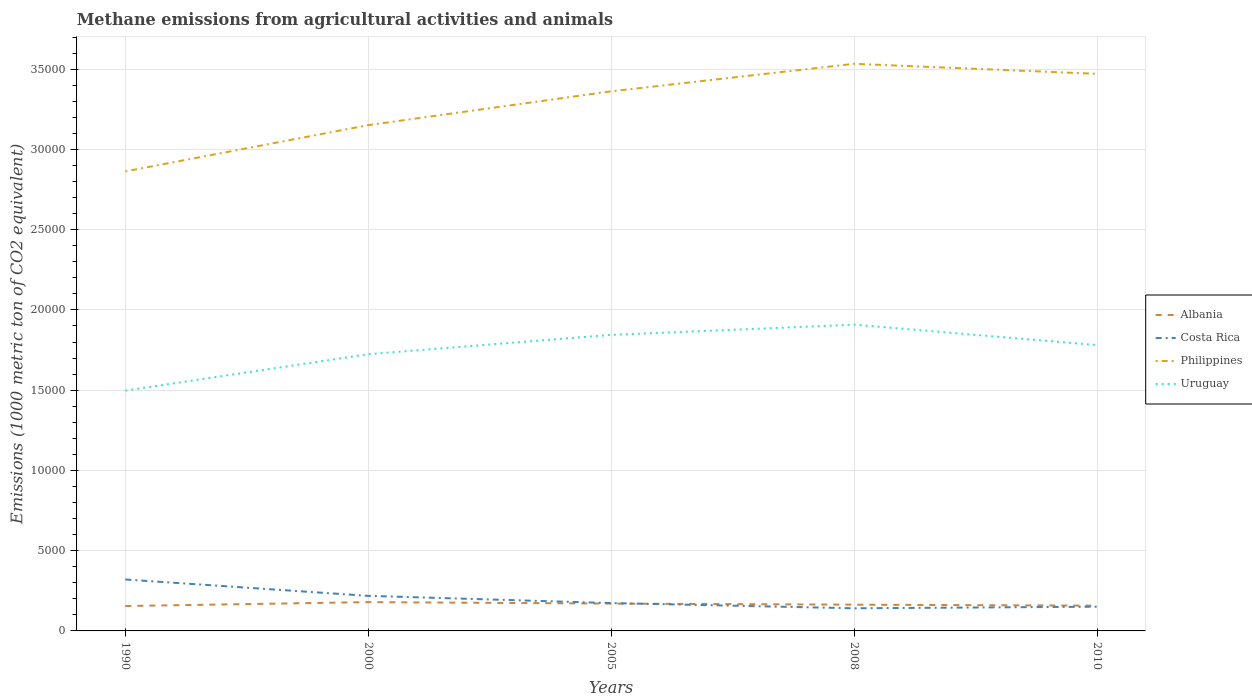How many different coloured lines are there?
Make the answer very short. 4. Is the number of lines equal to the number of legend labels?
Make the answer very short. Yes. Across all years, what is the maximum amount of methane emitted in Philippines?
Offer a very short reply. 2.86e+04. In which year was the amount of methane emitted in Costa Rica maximum?
Keep it short and to the point. 2008. What is the total amount of methane emitted in Costa Rica in the graph?
Your response must be concise. 1020. What is the difference between the highest and the second highest amount of methane emitted in Philippines?
Provide a short and direct response. 6703.2. How many lines are there?
Make the answer very short. 4. How many years are there in the graph?
Make the answer very short. 5. Are the values on the major ticks of Y-axis written in scientific E-notation?
Offer a terse response. No. Does the graph contain any zero values?
Offer a terse response. No. Does the graph contain grids?
Make the answer very short. Yes. How are the legend labels stacked?
Ensure brevity in your answer.  Vertical. What is the title of the graph?
Your answer should be very brief. Methane emissions from agricultural activities and animals. Does "Angola" appear as one of the legend labels in the graph?
Keep it short and to the point. No. What is the label or title of the X-axis?
Keep it short and to the point. Years. What is the label or title of the Y-axis?
Your response must be concise. Emissions (1000 metric ton of CO2 equivalent). What is the Emissions (1000 metric ton of CO2 equivalent) of Albania in 1990?
Offer a very short reply. 1550.9. What is the Emissions (1000 metric ton of CO2 equivalent) in Costa Rica in 1990?
Your answer should be very brief. 3204.6. What is the Emissions (1000 metric ton of CO2 equivalent) in Philippines in 1990?
Provide a succinct answer. 2.86e+04. What is the Emissions (1000 metric ton of CO2 equivalent) in Uruguay in 1990?
Ensure brevity in your answer.  1.50e+04. What is the Emissions (1000 metric ton of CO2 equivalent) of Albania in 2000?
Give a very brief answer. 1794.6. What is the Emissions (1000 metric ton of CO2 equivalent) of Costa Rica in 2000?
Keep it short and to the point. 2184.6. What is the Emissions (1000 metric ton of CO2 equivalent) in Philippines in 2000?
Offer a terse response. 3.15e+04. What is the Emissions (1000 metric ton of CO2 equivalent) in Uruguay in 2000?
Your answer should be very brief. 1.72e+04. What is the Emissions (1000 metric ton of CO2 equivalent) of Albania in 2005?
Offer a very short reply. 1702.9. What is the Emissions (1000 metric ton of CO2 equivalent) of Costa Rica in 2005?
Offer a very short reply. 1735. What is the Emissions (1000 metric ton of CO2 equivalent) in Philippines in 2005?
Offer a very short reply. 3.36e+04. What is the Emissions (1000 metric ton of CO2 equivalent) of Uruguay in 2005?
Offer a terse response. 1.84e+04. What is the Emissions (1000 metric ton of CO2 equivalent) of Albania in 2008?
Ensure brevity in your answer.  1635.8. What is the Emissions (1000 metric ton of CO2 equivalent) in Costa Rica in 2008?
Your response must be concise. 1409.6. What is the Emissions (1000 metric ton of CO2 equivalent) of Philippines in 2008?
Offer a terse response. 3.53e+04. What is the Emissions (1000 metric ton of CO2 equivalent) in Uruguay in 2008?
Offer a terse response. 1.91e+04. What is the Emissions (1000 metric ton of CO2 equivalent) in Albania in 2010?
Provide a short and direct response. 1574.1. What is the Emissions (1000 metric ton of CO2 equivalent) in Costa Rica in 2010?
Give a very brief answer. 1509.2. What is the Emissions (1000 metric ton of CO2 equivalent) of Philippines in 2010?
Your answer should be very brief. 3.47e+04. What is the Emissions (1000 metric ton of CO2 equivalent) in Uruguay in 2010?
Give a very brief answer. 1.78e+04. Across all years, what is the maximum Emissions (1000 metric ton of CO2 equivalent) of Albania?
Your answer should be very brief. 1794.6. Across all years, what is the maximum Emissions (1000 metric ton of CO2 equivalent) of Costa Rica?
Ensure brevity in your answer.  3204.6. Across all years, what is the maximum Emissions (1000 metric ton of CO2 equivalent) in Philippines?
Your answer should be very brief. 3.53e+04. Across all years, what is the maximum Emissions (1000 metric ton of CO2 equivalent) in Uruguay?
Your response must be concise. 1.91e+04. Across all years, what is the minimum Emissions (1000 metric ton of CO2 equivalent) of Albania?
Provide a short and direct response. 1550.9. Across all years, what is the minimum Emissions (1000 metric ton of CO2 equivalent) of Costa Rica?
Provide a short and direct response. 1409.6. Across all years, what is the minimum Emissions (1000 metric ton of CO2 equivalent) in Philippines?
Offer a very short reply. 2.86e+04. Across all years, what is the minimum Emissions (1000 metric ton of CO2 equivalent) in Uruguay?
Offer a very short reply. 1.50e+04. What is the total Emissions (1000 metric ton of CO2 equivalent) of Albania in the graph?
Ensure brevity in your answer.  8258.3. What is the total Emissions (1000 metric ton of CO2 equivalent) in Costa Rica in the graph?
Ensure brevity in your answer.  1.00e+04. What is the total Emissions (1000 metric ton of CO2 equivalent) in Philippines in the graph?
Give a very brief answer. 1.64e+05. What is the total Emissions (1000 metric ton of CO2 equivalent) of Uruguay in the graph?
Provide a succinct answer. 8.75e+04. What is the difference between the Emissions (1000 metric ton of CO2 equivalent) of Albania in 1990 and that in 2000?
Give a very brief answer. -243.7. What is the difference between the Emissions (1000 metric ton of CO2 equivalent) in Costa Rica in 1990 and that in 2000?
Keep it short and to the point. 1020. What is the difference between the Emissions (1000 metric ton of CO2 equivalent) in Philippines in 1990 and that in 2000?
Offer a terse response. -2881.3. What is the difference between the Emissions (1000 metric ton of CO2 equivalent) of Uruguay in 1990 and that in 2000?
Provide a succinct answer. -2267.7. What is the difference between the Emissions (1000 metric ton of CO2 equivalent) in Albania in 1990 and that in 2005?
Make the answer very short. -152. What is the difference between the Emissions (1000 metric ton of CO2 equivalent) in Costa Rica in 1990 and that in 2005?
Your answer should be very brief. 1469.6. What is the difference between the Emissions (1000 metric ton of CO2 equivalent) in Philippines in 1990 and that in 2005?
Keep it short and to the point. -4989.5. What is the difference between the Emissions (1000 metric ton of CO2 equivalent) in Uruguay in 1990 and that in 2005?
Your response must be concise. -3472.5. What is the difference between the Emissions (1000 metric ton of CO2 equivalent) of Albania in 1990 and that in 2008?
Keep it short and to the point. -84.9. What is the difference between the Emissions (1000 metric ton of CO2 equivalent) of Costa Rica in 1990 and that in 2008?
Ensure brevity in your answer.  1795. What is the difference between the Emissions (1000 metric ton of CO2 equivalent) in Philippines in 1990 and that in 2008?
Ensure brevity in your answer.  -6703.2. What is the difference between the Emissions (1000 metric ton of CO2 equivalent) in Uruguay in 1990 and that in 2008?
Your answer should be compact. -4108.2. What is the difference between the Emissions (1000 metric ton of CO2 equivalent) in Albania in 1990 and that in 2010?
Provide a succinct answer. -23.2. What is the difference between the Emissions (1000 metric ton of CO2 equivalent) in Costa Rica in 1990 and that in 2010?
Make the answer very short. 1695.4. What is the difference between the Emissions (1000 metric ton of CO2 equivalent) in Philippines in 1990 and that in 2010?
Your response must be concise. -6077.5. What is the difference between the Emissions (1000 metric ton of CO2 equivalent) of Uruguay in 1990 and that in 2010?
Your answer should be very brief. -2833.1. What is the difference between the Emissions (1000 metric ton of CO2 equivalent) of Albania in 2000 and that in 2005?
Provide a short and direct response. 91.7. What is the difference between the Emissions (1000 metric ton of CO2 equivalent) in Costa Rica in 2000 and that in 2005?
Your answer should be very brief. 449.6. What is the difference between the Emissions (1000 metric ton of CO2 equivalent) of Philippines in 2000 and that in 2005?
Offer a terse response. -2108.2. What is the difference between the Emissions (1000 metric ton of CO2 equivalent) in Uruguay in 2000 and that in 2005?
Make the answer very short. -1204.8. What is the difference between the Emissions (1000 metric ton of CO2 equivalent) of Albania in 2000 and that in 2008?
Make the answer very short. 158.8. What is the difference between the Emissions (1000 metric ton of CO2 equivalent) of Costa Rica in 2000 and that in 2008?
Give a very brief answer. 775. What is the difference between the Emissions (1000 metric ton of CO2 equivalent) in Philippines in 2000 and that in 2008?
Offer a terse response. -3821.9. What is the difference between the Emissions (1000 metric ton of CO2 equivalent) of Uruguay in 2000 and that in 2008?
Your answer should be compact. -1840.5. What is the difference between the Emissions (1000 metric ton of CO2 equivalent) in Albania in 2000 and that in 2010?
Make the answer very short. 220.5. What is the difference between the Emissions (1000 metric ton of CO2 equivalent) of Costa Rica in 2000 and that in 2010?
Ensure brevity in your answer.  675.4. What is the difference between the Emissions (1000 metric ton of CO2 equivalent) of Philippines in 2000 and that in 2010?
Make the answer very short. -3196.2. What is the difference between the Emissions (1000 metric ton of CO2 equivalent) in Uruguay in 2000 and that in 2010?
Provide a short and direct response. -565.4. What is the difference between the Emissions (1000 metric ton of CO2 equivalent) in Albania in 2005 and that in 2008?
Your answer should be very brief. 67.1. What is the difference between the Emissions (1000 metric ton of CO2 equivalent) of Costa Rica in 2005 and that in 2008?
Make the answer very short. 325.4. What is the difference between the Emissions (1000 metric ton of CO2 equivalent) of Philippines in 2005 and that in 2008?
Give a very brief answer. -1713.7. What is the difference between the Emissions (1000 metric ton of CO2 equivalent) of Uruguay in 2005 and that in 2008?
Your answer should be compact. -635.7. What is the difference between the Emissions (1000 metric ton of CO2 equivalent) in Albania in 2005 and that in 2010?
Your answer should be compact. 128.8. What is the difference between the Emissions (1000 metric ton of CO2 equivalent) in Costa Rica in 2005 and that in 2010?
Offer a terse response. 225.8. What is the difference between the Emissions (1000 metric ton of CO2 equivalent) in Philippines in 2005 and that in 2010?
Your answer should be compact. -1088. What is the difference between the Emissions (1000 metric ton of CO2 equivalent) of Uruguay in 2005 and that in 2010?
Your answer should be very brief. 639.4. What is the difference between the Emissions (1000 metric ton of CO2 equivalent) of Albania in 2008 and that in 2010?
Your answer should be compact. 61.7. What is the difference between the Emissions (1000 metric ton of CO2 equivalent) in Costa Rica in 2008 and that in 2010?
Offer a terse response. -99.6. What is the difference between the Emissions (1000 metric ton of CO2 equivalent) of Philippines in 2008 and that in 2010?
Provide a short and direct response. 625.7. What is the difference between the Emissions (1000 metric ton of CO2 equivalent) in Uruguay in 2008 and that in 2010?
Your answer should be compact. 1275.1. What is the difference between the Emissions (1000 metric ton of CO2 equivalent) of Albania in 1990 and the Emissions (1000 metric ton of CO2 equivalent) of Costa Rica in 2000?
Your response must be concise. -633.7. What is the difference between the Emissions (1000 metric ton of CO2 equivalent) in Albania in 1990 and the Emissions (1000 metric ton of CO2 equivalent) in Philippines in 2000?
Your response must be concise. -3.00e+04. What is the difference between the Emissions (1000 metric ton of CO2 equivalent) of Albania in 1990 and the Emissions (1000 metric ton of CO2 equivalent) of Uruguay in 2000?
Make the answer very short. -1.57e+04. What is the difference between the Emissions (1000 metric ton of CO2 equivalent) of Costa Rica in 1990 and the Emissions (1000 metric ton of CO2 equivalent) of Philippines in 2000?
Make the answer very short. -2.83e+04. What is the difference between the Emissions (1000 metric ton of CO2 equivalent) in Costa Rica in 1990 and the Emissions (1000 metric ton of CO2 equivalent) in Uruguay in 2000?
Offer a very short reply. -1.40e+04. What is the difference between the Emissions (1000 metric ton of CO2 equivalent) of Philippines in 1990 and the Emissions (1000 metric ton of CO2 equivalent) of Uruguay in 2000?
Provide a short and direct response. 1.14e+04. What is the difference between the Emissions (1000 metric ton of CO2 equivalent) of Albania in 1990 and the Emissions (1000 metric ton of CO2 equivalent) of Costa Rica in 2005?
Your answer should be very brief. -184.1. What is the difference between the Emissions (1000 metric ton of CO2 equivalent) of Albania in 1990 and the Emissions (1000 metric ton of CO2 equivalent) of Philippines in 2005?
Make the answer very short. -3.21e+04. What is the difference between the Emissions (1000 metric ton of CO2 equivalent) in Albania in 1990 and the Emissions (1000 metric ton of CO2 equivalent) in Uruguay in 2005?
Give a very brief answer. -1.69e+04. What is the difference between the Emissions (1000 metric ton of CO2 equivalent) of Costa Rica in 1990 and the Emissions (1000 metric ton of CO2 equivalent) of Philippines in 2005?
Your answer should be compact. -3.04e+04. What is the difference between the Emissions (1000 metric ton of CO2 equivalent) of Costa Rica in 1990 and the Emissions (1000 metric ton of CO2 equivalent) of Uruguay in 2005?
Give a very brief answer. -1.52e+04. What is the difference between the Emissions (1000 metric ton of CO2 equivalent) in Philippines in 1990 and the Emissions (1000 metric ton of CO2 equivalent) in Uruguay in 2005?
Offer a very short reply. 1.02e+04. What is the difference between the Emissions (1000 metric ton of CO2 equivalent) of Albania in 1990 and the Emissions (1000 metric ton of CO2 equivalent) of Costa Rica in 2008?
Offer a very short reply. 141.3. What is the difference between the Emissions (1000 metric ton of CO2 equivalent) in Albania in 1990 and the Emissions (1000 metric ton of CO2 equivalent) in Philippines in 2008?
Provide a succinct answer. -3.38e+04. What is the difference between the Emissions (1000 metric ton of CO2 equivalent) in Albania in 1990 and the Emissions (1000 metric ton of CO2 equivalent) in Uruguay in 2008?
Provide a short and direct response. -1.75e+04. What is the difference between the Emissions (1000 metric ton of CO2 equivalent) of Costa Rica in 1990 and the Emissions (1000 metric ton of CO2 equivalent) of Philippines in 2008?
Keep it short and to the point. -3.21e+04. What is the difference between the Emissions (1000 metric ton of CO2 equivalent) of Costa Rica in 1990 and the Emissions (1000 metric ton of CO2 equivalent) of Uruguay in 2008?
Your answer should be very brief. -1.59e+04. What is the difference between the Emissions (1000 metric ton of CO2 equivalent) in Philippines in 1990 and the Emissions (1000 metric ton of CO2 equivalent) in Uruguay in 2008?
Give a very brief answer. 9549.1. What is the difference between the Emissions (1000 metric ton of CO2 equivalent) in Albania in 1990 and the Emissions (1000 metric ton of CO2 equivalent) in Costa Rica in 2010?
Offer a terse response. 41.7. What is the difference between the Emissions (1000 metric ton of CO2 equivalent) of Albania in 1990 and the Emissions (1000 metric ton of CO2 equivalent) of Philippines in 2010?
Your answer should be compact. -3.32e+04. What is the difference between the Emissions (1000 metric ton of CO2 equivalent) of Albania in 1990 and the Emissions (1000 metric ton of CO2 equivalent) of Uruguay in 2010?
Give a very brief answer. -1.63e+04. What is the difference between the Emissions (1000 metric ton of CO2 equivalent) in Costa Rica in 1990 and the Emissions (1000 metric ton of CO2 equivalent) in Philippines in 2010?
Make the answer very short. -3.15e+04. What is the difference between the Emissions (1000 metric ton of CO2 equivalent) in Costa Rica in 1990 and the Emissions (1000 metric ton of CO2 equivalent) in Uruguay in 2010?
Your answer should be very brief. -1.46e+04. What is the difference between the Emissions (1000 metric ton of CO2 equivalent) of Philippines in 1990 and the Emissions (1000 metric ton of CO2 equivalent) of Uruguay in 2010?
Make the answer very short. 1.08e+04. What is the difference between the Emissions (1000 metric ton of CO2 equivalent) in Albania in 2000 and the Emissions (1000 metric ton of CO2 equivalent) in Costa Rica in 2005?
Your answer should be compact. 59.6. What is the difference between the Emissions (1000 metric ton of CO2 equivalent) of Albania in 2000 and the Emissions (1000 metric ton of CO2 equivalent) of Philippines in 2005?
Offer a terse response. -3.18e+04. What is the difference between the Emissions (1000 metric ton of CO2 equivalent) of Albania in 2000 and the Emissions (1000 metric ton of CO2 equivalent) of Uruguay in 2005?
Ensure brevity in your answer.  -1.67e+04. What is the difference between the Emissions (1000 metric ton of CO2 equivalent) in Costa Rica in 2000 and the Emissions (1000 metric ton of CO2 equivalent) in Philippines in 2005?
Your response must be concise. -3.14e+04. What is the difference between the Emissions (1000 metric ton of CO2 equivalent) in Costa Rica in 2000 and the Emissions (1000 metric ton of CO2 equivalent) in Uruguay in 2005?
Your response must be concise. -1.63e+04. What is the difference between the Emissions (1000 metric ton of CO2 equivalent) in Philippines in 2000 and the Emissions (1000 metric ton of CO2 equivalent) in Uruguay in 2005?
Your response must be concise. 1.31e+04. What is the difference between the Emissions (1000 metric ton of CO2 equivalent) in Albania in 2000 and the Emissions (1000 metric ton of CO2 equivalent) in Costa Rica in 2008?
Provide a short and direct response. 385. What is the difference between the Emissions (1000 metric ton of CO2 equivalent) in Albania in 2000 and the Emissions (1000 metric ton of CO2 equivalent) in Philippines in 2008?
Offer a very short reply. -3.35e+04. What is the difference between the Emissions (1000 metric ton of CO2 equivalent) of Albania in 2000 and the Emissions (1000 metric ton of CO2 equivalent) of Uruguay in 2008?
Keep it short and to the point. -1.73e+04. What is the difference between the Emissions (1000 metric ton of CO2 equivalent) of Costa Rica in 2000 and the Emissions (1000 metric ton of CO2 equivalent) of Philippines in 2008?
Keep it short and to the point. -3.31e+04. What is the difference between the Emissions (1000 metric ton of CO2 equivalent) of Costa Rica in 2000 and the Emissions (1000 metric ton of CO2 equivalent) of Uruguay in 2008?
Make the answer very short. -1.69e+04. What is the difference between the Emissions (1000 metric ton of CO2 equivalent) of Philippines in 2000 and the Emissions (1000 metric ton of CO2 equivalent) of Uruguay in 2008?
Offer a terse response. 1.24e+04. What is the difference between the Emissions (1000 metric ton of CO2 equivalent) in Albania in 2000 and the Emissions (1000 metric ton of CO2 equivalent) in Costa Rica in 2010?
Ensure brevity in your answer.  285.4. What is the difference between the Emissions (1000 metric ton of CO2 equivalent) in Albania in 2000 and the Emissions (1000 metric ton of CO2 equivalent) in Philippines in 2010?
Make the answer very short. -3.29e+04. What is the difference between the Emissions (1000 metric ton of CO2 equivalent) in Albania in 2000 and the Emissions (1000 metric ton of CO2 equivalent) in Uruguay in 2010?
Offer a very short reply. -1.60e+04. What is the difference between the Emissions (1000 metric ton of CO2 equivalent) in Costa Rica in 2000 and the Emissions (1000 metric ton of CO2 equivalent) in Philippines in 2010?
Make the answer very short. -3.25e+04. What is the difference between the Emissions (1000 metric ton of CO2 equivalent) in Costa Rica in 2000 and the Emissions (1000 metric ton of CO2 equivalent) in Uruguay in 2010?
Give a very brief answer. -1.56e+04. What is the difference between the Emissions (1000 metric ton of CO2 equivalent) in Philippines in 2000 and the Emissions (1000 metric ton of CO2 equivalent) in Uruguay in 2010?
Offer a very short reply. 1.37e+04. What is the difference between the Emissions (1000 metric ton of CO2 equivalent) in Albania in 2005 and the Emissions (1000 metric ton of CO2 equivalent) in Costa Rica in 2008?
Offer a terse response. 293.3. What is the difference between the Emissions (1000 metric ton of CO2 equivalent) in Albania in 2005 and the Emissions (1000 metric ton of CO2 equivalent) in Philippines in 2008?
Make the answer very short. -3.36e+04. What is the difference between the Emissions (1000 metric ton of CO2 equivalent) of Albania in 2005 and the Emissions (1000 metric ton of CO2 equivalent) of Uruguay in 2008?
Give a very brief answer. -1.74e+04. What is the difference between the Emissions (1000 metric ton of CO2 equivalent) of Costa Rica in 2005 and the Emissions (1000 metric ton of CO2 equivalent) of Philippines in 2008?
Your answer should be very brief. -3.36e+04. What is the difference between the Emissions (1000 metric ton of CO2 equivalent) of Costa Rica in 2005 and the Emissions (1000 metric ton of CO2 equivalent) of Uruguay in 2008?
Keep it short and to the point. -1.73e+04. What is the difference between the Emissions (1000 metric ton of CO2 equivalent) of Philippines in 2005 and the Emissions (1000 metric ton of CO2 equivalent) of Uruguay in 2008?
Give a very brief answer. 1.45e+04. What is the difference between the Emissions (1000 metric ton of CO2 equivalent) in Albania in 2005 and the Emissions (1000 metric ton of CO2 equivalent) in Costa Rica in 2010?
Your response must be concise. 193.7. What is the difference between the Emissions (1000 metric ton of CO2 equivalent) of Albania in 2005 and the Emissions (1000 metric ton of CO2 equivalent) of Philippines in 2010?
Offer a terse response. -3.30e+04. What is the difference between the Emissions (1000 metric ton of CO2 equivalent) in Albania in 2005 and the Emissions (1000 metric ton of CO2 equivalent) in Uruguay in 2010?
Keep it short and to the point. -1.61e+04. What is the difference between the Emissions (1000 metric ton of CO2 equivalent) of Costa Rica in 2005 and the Emissions (1000 metric ton of CO2 equivalent) of Philippines in 2010?
Provide a succinct answer. -3.30e+04. What is the difference between the Emissions (1000 metric ton of CO2 equivalent) of Costa Rica in 2005 and the Emissions (1000 metric ton of CO2 equivalent) of Uruguay in 2010?
Keep it short and to the point. -1.61e+04. What is the difference between the Emissions (1000 metric ton of CO2 equivalent) in Philippines in 2005 and the Emissions (1000 metric ton of CO2 equivalent) in Uruguay in 2010?
Your response must be concise. 1.58e+04. What is the difference between the Emissions (1000 metric ton of CO2 equivalent) of Albania in 2008 and the Emissions (1000 metric ton of CO2 equivalent) of Costa Rica in 2010?
Offer a terse response. 126.6. What is the difference between the Emissions (1000 metric ton of CO2 equivalent) in Albania in 2008 and the Emissions (1000 metric ton of CO2 equivalent) in Philippines in 2010?
Ensure brevity in your answer.  -3.31e+04. What is the difference between the Emissions (1000 metric ton of CO2 equivalent) of Albania in 2008 and the Emissions (1000 metric ton of CO2 equivalent) of Uruguay in 2010?
Your answer should be compact. -1.62e+04. What is the difference between the Emissions (1000 metric ton of CO2 equivalent) in Costa Rica in 2008 and the Emissions (1000 metric ton of CO2 equivalent) in Philippines in 2010?
Ensure brevity in your answer.  -3.33e+04. What is the difference between the Emissions (1000 metric ton of CO2 equivalent) of Costa Rica in 2008 and the Emissions (1000 metric ton of CO2 equivalent) of Uruguay in 2010?
Provide a short and direct response. -1.64e+04. What is the difference between the Emissions (1000 metric ton of CO2 equivalent) of Philippines in 2008 and the Emissions (1000 metric ton of CO2 equivalent) of Uruguay in 2010?
Your response must be concise. 1.75e+04. What is the average Emissions (1000 metric ton of CO2 equivalent) of Albania per year?
Ensure brevity in your answer.  1651.66. What is the average Emissions (1000 metric ton of CO2 equivalent) of Costa Rica per year?
Provide a succinct answer. 2008.6. What is the average Emissions (1000 metric ton of CO2 equivalent) of Philippines per year?
Offer a very short reply. 3.28e+04. What is the average Emissions (1000 metric ton of CO2 equivalent) in Uruguay per year?
Your answer should be very brief. 1.75e+04. In the year 1990, what is the difference between the Emissions (1000 metric ton of CO2 equivalent) in Albania and Emissions (1000 metric ton of CO2 equivalent) in Costa Rica?
Give a very brief answer. -1653.7. In the year 1990, what is the difference between the Emissions (1000 metric ton of CO2 equivalent) in Albania and Emissions (1000 metric ton of CO2 equivalent) in Philippines?
Ensure brevity in your answer.  -2.71e+04. In the year 1990, what is the difference between the Emissions (1000 metric ton of CO2 equivalent) of Albania and Emissions (1000 metric ton of CO2 equivalent) of Uruguay?
Offer a very short reply. -1.34e+04. In the year 1990, what is the difference between the Emissions (1000 metric ton of CO2 equivalent) in Costa Rica and Emissions (1000 metric ton of CO2 equivalent) in Philippines?
Ensure brevity in your answer.  -2.54e+04. In the year 1990, what is the difference between the Emissions (1000 metric ton of CO2 equivalent) in Costa Rica and Emissions (1000 metric ton of CO2 equivalent) in Uruguay?
Provide a succinct answer. -1.18e+04. In the year 1990, what is the difference between the Emissions (1000 metric ton of CO2 equivalent) of Philippines and Emissions (1000 metric ton of CO2 equivalent) of Uruguay?
Make the answer very short. 1.37e+04. In the year 2000, what is the difference between the Emissions (1000 metric ton of CO2 equivalent) of Albania and Emissions (1000 metric ton of CO2 equivalent) of Costa Rica?
Your response must be concise. -390. In the year 2000, what is the difference between the Emissions (1000 metric ton of CO2 equivalent) of Albania and Emissions (1000 metric ton of CO2 equivalent) of Philippines?
Your answer should be very brief. -2.97e+04. In the year 2000, what is the difference between the Emissions (1000 metric ton of CO2 equivalent) of Albania and Emissions (1000 metric ton of CO2 equivalent) of Uruguay?
Ensure brevity in your answer.  -1.54e+04. In the year 2000, what is the difference between the Emissions (1000 metric ton of CO2 equivalent) in Costa Rica and Emissions (1000 metric ton of CO2 equivalent) in Philippines?
Ensure brevity in your answer.  -2.93e+04. In the year 2000, what is the difference between the Emissions (1000 metric ton of CO2 equivalent) in Costa Rica and Emissions (1000 metric ton of CO2 equivalent) in Uruguay?
Offer a very short reply. -1.51e+04. In the year 2000, what is the difference between the Emissions (1000 metric ton of CO2 equivalent) in Philippines and Emissions (1000 metric ton of CO2 equivalent) in Uruguay?
Your response must be concise. 1.43e+04. In the year 2005, what is the difference between the Emissions (1000 metric ton of CO2 equivalent) in Albania and Emissions (1000 metric ton of CO2 equivalent) in Costa Rica?
Give a very brief answer. -32.1. In the year 2005, what is the difference between the Emissions (1000 metric ton of CO2 equivalent) in Albania and Emissions (1000 metric ton of CO2 equivalent) in Philippines?
Give a very brief answer. -3.19e+04. In the year 2005, what is the difference between the Emissions (1000 metric ton of CO2 equivalent) of Albania and Emissions (1000 metric ton of CO2 equivalent) of Uruguay?
Your response must be concise. -1.67e+04. In the year 2005, what is the difference between the Emissions (1000 metric ton of CO2 equivalent) of Costa Rica and Emissions (1000 metric ton of CO2 equivalent) of Philippines?
Your answer should be compact. -3.19e+04. In the year 2005, what is the difference between the Emissions (1000 metric ton of CO2 equivalent) in Costa Rica and Emissions (1000 metric ton of CO2 equivalent) in Uruguay?
Your answer should be very brief. -1.67e+04. In the year 2005, what is the difference between the Emissions (1000 metric ton of CO2 equivalent) in Philippines and Emissions (1000 metric ton of CO2 equivalent) in Uruguay?
Provide a succinct answer. 1.52e+04. In the year 2008, what is the difference between the Emissions (1000 metric ton of CO2 equivalent) in Albania and Emissions (1000 metric ton of CO2 equivalent) in Costa Rica?
Your response must be concise. 226.2. In the year 2008, what is the difference between the Emissions (1000 metric ton of CO2 equivalent) of Albania and Emissions (1000 metric ton of CO2 equivalent) of Philippines?
Give a very brief answer. -3.37e+04. In the year 2008, what is the difference between the Emissions (1000 metric ton of CO2 equivalent) in Albania and Emissions (1000 metric ton of CO2 equivalent) in Uruguay?
Your answer should be very brief. -1.74e+04. In the year 2008, what is the difference between the Emissions (1000 metric ton of CO2 equivalent) of Costa Rica and Emissions (1000 metric ton of CO2 equivalent) of Philippines?
Ensure brevity in your answer.  -3.39e+04. In the year 2008, what is the difference between the Emissions (1000 metric ton of CO2 equivalent) in Costa Rica and Emissions (1000 metric ton of CO2 equivalent) in Uruguay?
Your response must be concise. -1.77e+04. In the year 2008, what is the difference between the Emissions (1000 metric ton of CO2 equivalent) in Philippines and Emissions (1000 metric ton of CO2 equivalent) in Uruguay?
Keep it short and to the point. 1.63e+04. In the year 2010, what is the difference between the Emissions (1000 metric ton of CO2 equivalent) in Albania and Emissions (1000 metric ton of CO2 equivalent) in Costa Rica?
Offer a terse response. 64.9. In the year 2010, what is the difference between the Emissions (1000 metric ton of CO2 equivalent) in Albania and Emissions (1000 metric ton of CO2 equivalent) in Philippines?
Make the answer very short. -3.31e+04. In the year 2010, what is the difference between the Emissions (1000 metric ton of CO2 equivalent) of Albania and Emissions (1000 metric ton of CO2 equivalent) of Uruguay?
Your answer should be very brief. -1.62e+04. In the year 2010, what is the difference between the Emissions (1000 metric ton of CO2 equivalent) of Costa Rica and Emissions (1000 metric ton of CO2 equivalent) of Philippines?
Ensure brevity in your answer.  -3.32e+04. In the year 2010, what is the difference between the Emissions (1000 metric ton of CO2 equivalent) in Costa Rica and Emissions (1000 metric ton of CO2 equivalent) in Uruguay?
Make the answer very short. -1.63e+04. In the year 2010, what is the difference between the Emissions (1000 metric ton of CO2 equivalent) of Philippines and Emissions (1000 metric ton of CO2 equivalent) of Uruguay?
Ensure brevity in your answer.  1.69e+04. What is the ratio of the Emissions (1000 metric ton of CO2 equivalent) of Albania in 1990 to that in 2000?
Ensure brevity in your answer.  0.86. What is the ratio of the Emissions (1000 metric ton of CO2 equivalent) of Costa Rica in 1990 to that in 2000?
Provide a short and direct response. 1.47. What is the ratio of the Emissions (1000 metric ton of CO2 equivalent) in Philippines in 1990 to that in 2000?
Provide a short and direct response. 0.91. What is the ratio of the Emissions (1000 metric ton of CO2 equivalent) in Uruguay in 1990 to that in 2000?
Ensure brevity in your answer.  0.87. What is the ratio of the Emissions (1000 metric ton of CO2 equivalent) in Albania in 1990 to that in 2005?
Offer a terse response. 0.91. What is the ratio of the Emissions (1000 metric ton of CO2 equivalent) in Costa Rica in 1990 to that in 2005?
Your answer should be very brief. 1.85. What is the ratio of the Emissions (1000 metric ton of CO2 equivalent) in Philippines in 1990 to that in 2005?
Provide a succinct answer. 0.85. What is the ratio of the Emissions (1000 metric ton of CO2 equivalent) of Uruguay in 1990 to that in 2005?
Offer a terse response. 0.81. What is the ratio of the Emissions (1000 metric ton of CO2 equivalent) in Albania in 1990 to that in 2008?
Offer a very short reply. 0.95. What is the ratio of the Emissions (1000 metric ton of CO2 equivalent) of Costa Rica in 1990 to that in 2008?
Offer a terse response. 2.27. What is the ratio of the Emissions (1000 metric ton of CO2 equivalent) of Philippines in 1990 to that in 2008?
Keep it short and to the point. 0.81. What is the ratio of the Emissions (1000 metric ton of CO2 equivalent) of Uruguay in 1990 to that in 2008?
Keep it short and to the point. 0.78. What is the ratio of the Emissions (1000 metric ton of CO2 equivalent) of Costa Rica in 1990 to that in 2010?
Keep it short and to the point. 2.12. What is the ratio of the Emissions (1000 metric ton of CO2 equivalent) of Philippines in 1990 to that in 2010?
Keep it short and to the point. 0.82. What is the ratio of the Emissions (1000 metric ton of CO2 equivalent) of Uruguay in 1990 to that in 2010?
Your answer should be very brief. 0.84. What is the ratio of the Emissions (1000 metric ton of CO2 equivalent) in Albania in 2000 to that in 2005?
Ensure brevity in your answer.  1.05. What is the ratio of the Emissions (1000 metric ton of CO2 equivalent) of Costa Rica in 2000 to that in 2005?
Your answer should be compact. 1.26. What is the ratio of the Emissions (1000 metric ton of CO2 equivalent) of Philippines in 2000 to that in 2005?
Offer a terse response. 0.94. What is the ratio of the Emissions (1000 metric ton of CO2 equivalent) in Uruguay in 2000 to that in 2005?
Provide a short and direct response. 0.93. What is the ratio of the Emissions (1000 metric ton of CO2 equivalent) in Albania in 2000 to that in 2008?
Provide a short and direct response. 1.1. What is the ratio of the Emissions (1000 metric ton of CO2 equivalent) in Costa Rica in 2000 to that in 2008?
Offer a terse response. 1.55. What is the ratio of the Emissions (1000 metric ton of CO2 equivalent) of Philippines in 2000 to that in 2008?
Your answer should be compact. 0.89. What is the ratio of the Emissions (1000 metric ton of CO2 equivalent) in Uruguay in 2000 to that in 2008?
Provide a succinct answer. 0.9. What is the ratio of the Emissions (1000 metric ton of CO2 equivalent) in Albania in 2000 to that in 2010?
Make the answer very short. 1.14. What is the ratio of the Emissions (1000 metric ton of CO2 equivalent) of Costa Rica in 2000 to that in 2010?
Offer a terse response. 1.45. What is the ratio of the Emissions (1000 metric ton of CO2 equivalent) in Philippines in 2000 to that in 2010?
Ensure brevity in your answer.  0.91. What is the ratio of the Emissions (1000 metric ton of CO2 equivalent) in Uruguay in 2000 to that in 2010?
Offer a very short reply. 0.97. What is the ratio of the Emissions (1000 metric ton of CO2 equivalent) in Albania in 2005 to that in 2008?
Offer a terse response. 1.04. What is the ratio of the Emissions (1000 metric ton of CO2 equivalent) in Costa Rica in 2005 to that in 2008?
Make the answer very short. 1.23. What is the ratio of the Emissions (1000 metric ton of CO2 equivalent) of Philippines in 2005 to that in 2008?
Your answer should be compact. 0.95. What is the ratio of the Emissions (1000 metric ton of CO2 equivalent) in Uruguay in 2005 to that in 2008?
Offer a terse response. 0.97. What is the ratio of the Emissions (1000 metric ton of CO2 equivalent) in Albania in 2005 to that in 2010?
Keep it short and to the point. 1.08. What is the ratio of the Emissions (1000 metric ton of CO2 equivalent) of Costa Rica in 2005 to that in 2010?
Ensure brevity in your answer.  1.15. What is the ratio of the Emissions (1000 metric ton of CO2 equivalent) in Philippines in 2005 to that in 2010?
Provide a succinct answer. 0.97. What is the ratio of the Emissions (1000 metric ton of CO2 equivalent) of Uruguay in 2005 to that in 2010?
Offer a very short reply. 1.04. What is the ratio of the Emissions (1000 metric ton of CO2 equivalent) in Albania in 2008 to that in 2010?
Provide a short and direct response. 1.04. What is the ratio of the Emissions (1000 metric ton of CO2 equivalent) of Costa Rica in 2008 to that in 2010?
Your answer should be very brief. 0.93. What is the ratio of the Emissions (1000 metric ton of CO2 equivalent) in Uruguay in 2008 to that in 2010?
Ensure brevity in your answer.  1.07. What is the difference between the highest and the second highest Emissions (1000 metric ton of CO2 equivalent) of Albania?
Make the answer very short. 91.7. What is the difference between the highest and the second highest Emissions (1000 metric ton of CO2 equivalent) in Costa Rica?
Provide a succinct answer. 1020. What is the difference between the highest and the second highest Emissions (1000 metric ton of CO2 equivalent) of Philippines?
Keep it short and to the point. 625.7. What is the difference between the highest and the second highest Emissions (1000 metric ton of CO2 equivalent) in Uruguay?
Provide a short and direct response. 635.7. What is the difference between the highest and the lowest Emissions (1000 metric ton of CO2 equivalent) in Albania?
Offer a very short reply. 243.7. What is the difference between the highest and the lowest Emissions (1000 metric ton of CO2 equivalent) of Costa Rica?
Your answer should be compact. 1795. What is the difference between the highest and the lowest Emissions (1000 metric ton of CO2 equivalent) in Philippines?
Your response must be concise. 6703.2. What is the difference between the highest and the lowest Emissions (1000 metric ton of CO2 equivalent) of Uruguay?
Your response must be concise. 4108.2. 